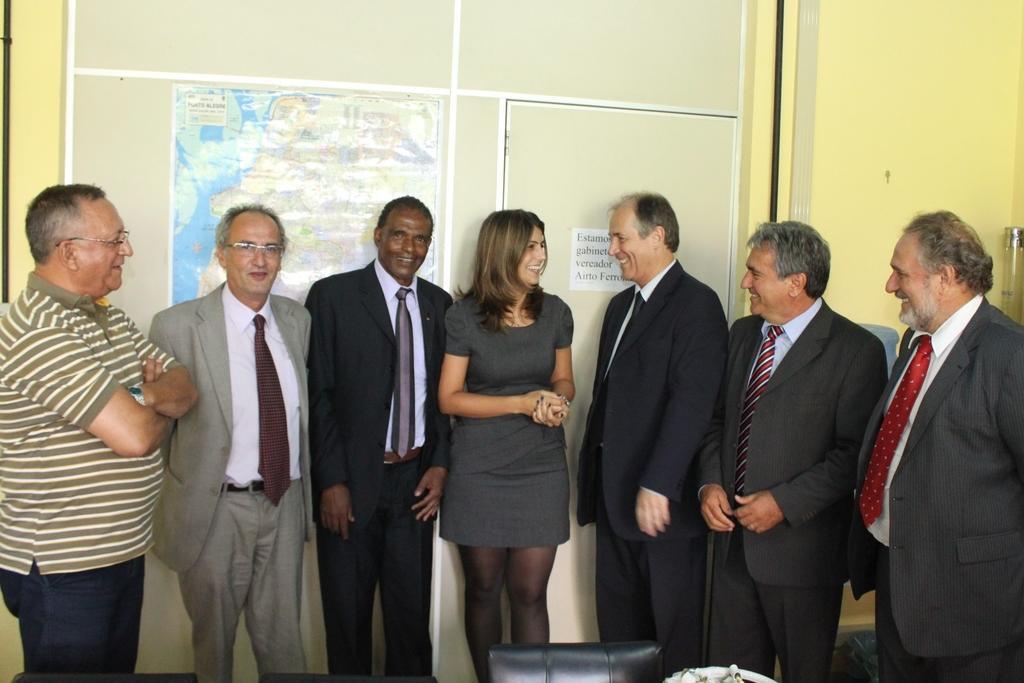How would you summarize this image in a sentence or two? In this image I can see people standing. There is a chair in the bottom of the image. There is a map attached at the back. 